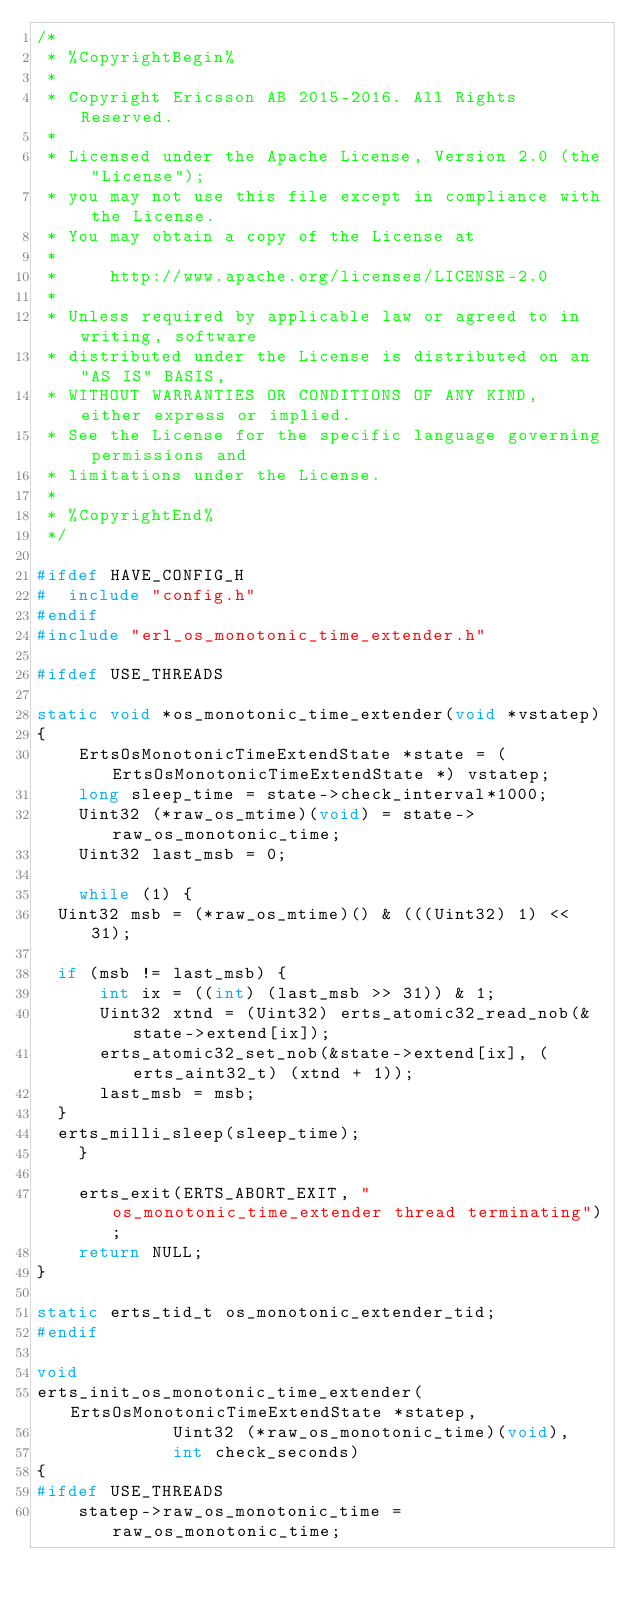Convert code to text. <code><loc_0><loc_0><loc_500><loc_500><_C_>/*
 * %CopyrightBegin%
 * 
 * Copyright Ericsson AB 2015-2016. All Rights Reserved.
 * 
 * Licensed under the Apache License, Version 2.0 (the "License");
 * you may not use this file except in compliance with the License.
 * You may obtain a copy of the License at
 *
 *     http://www.apache.org/licenses/LICENSE-2.0
 *
 * Unless required by applicable law or agreed to in writing, software
 * distributed under the License is distributed on an "AS IS" BASIS,
 * WITHOUT WARRANTIES OR CONDITIONS OF ANY KIND, either express or implied.
 * See the License for the specific language governing permissions and
 * limitations under the License.
 * 
 * %CopyrightEnd%
 */

#ifdef HAVE_CONFIG_H
#  include "config.h"
#endif
#include "erl_os_monotonic_time_extender.h"

#ifdef USE_THREADS

static void *os_monotonic_time_extender(void *vstatep)
{
    ErtsOsMonotonicTimeExtendState *state = (ErtsOsMonotonicTimeExtendState *) vstatep;
    long sleep_time = state->check_interval*1000;
    Uint32 (*raw_os_mtime)(void) = state->raw_os_monotonic_time;
    Uint32 last_msb = 0;

    while (1) {
	Uint32 msb = (*raw_os_mtime)() & (((Uint32) 1) << 31);

	if (msb != last_msb) {
	    int ix = ((int) (last_msb >> 31)) & 1;
	    Uint32 xtnd = (Uint32) erts_atomic32_read_nob(&state->extend[ix]);
	    erts_atomic32_set_nob(&state->extend[ix], (erts_aint32_t) (xtnd + 1));
	    last_msb = msb;
	}
	erts_milli_sleep(sleep_time);
    }

    erts_exit(ERTS_ABORT_EXIT, "os_monotonic_time_extender thread terminating");
    return NULL;
}

static erts_tid_t os_monotonic_extender_tid;
#endif

void
erts_init_os_monotonic_time_extender(ErtsOsMonotonicTimeExtendState *statep,
				     Uint32 (*raw_os_monotonic_time)(void),
				     int check_seconds)
{
#ifdef USE_THREADS
    statep->raw_os_monotonic_time = raw_os_monotonic_time;</code> 